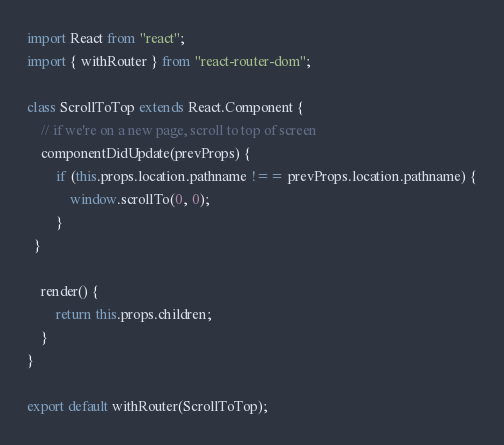Convert code to text. <code><loc_0><loc_0><loc_500><loc_500><_JavaScript_>import React from "react";
import { withRouter } from "react-router-dom";

class ScrollToTop extends React.Component {
    // if we're on a new page, scroll to top of screen
    componentDidUpdate(prevProps) {
        if (this.props.location.pathname !== prevProps.location.pathname) {
            window.scrollTo(0, 0);
        }
  }

    render() {
        return this.props.children;
    }
}

export default withRouter(ScrollToTop);</code> 